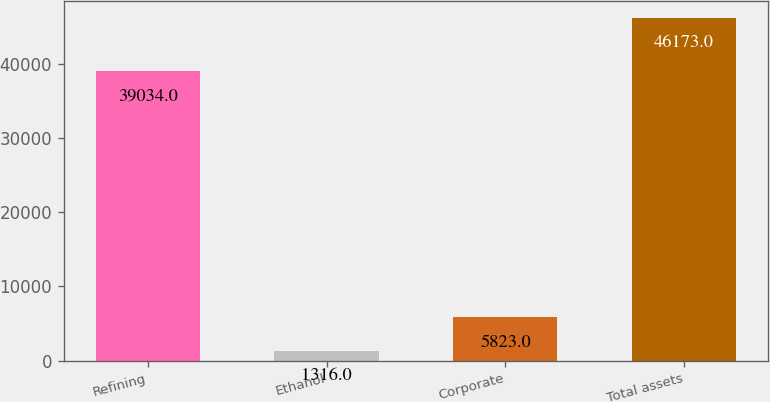Convert chart. <chart><loc_0><loc_0><loc_500><loc_500><bar_chart><fcel>Refining<fcel>Ethanol<fcel>Corporate<fcel>Total assets<nl><fcel>39034<fcel>1316<fcel>5823<fcel>46173<nl></chart> 